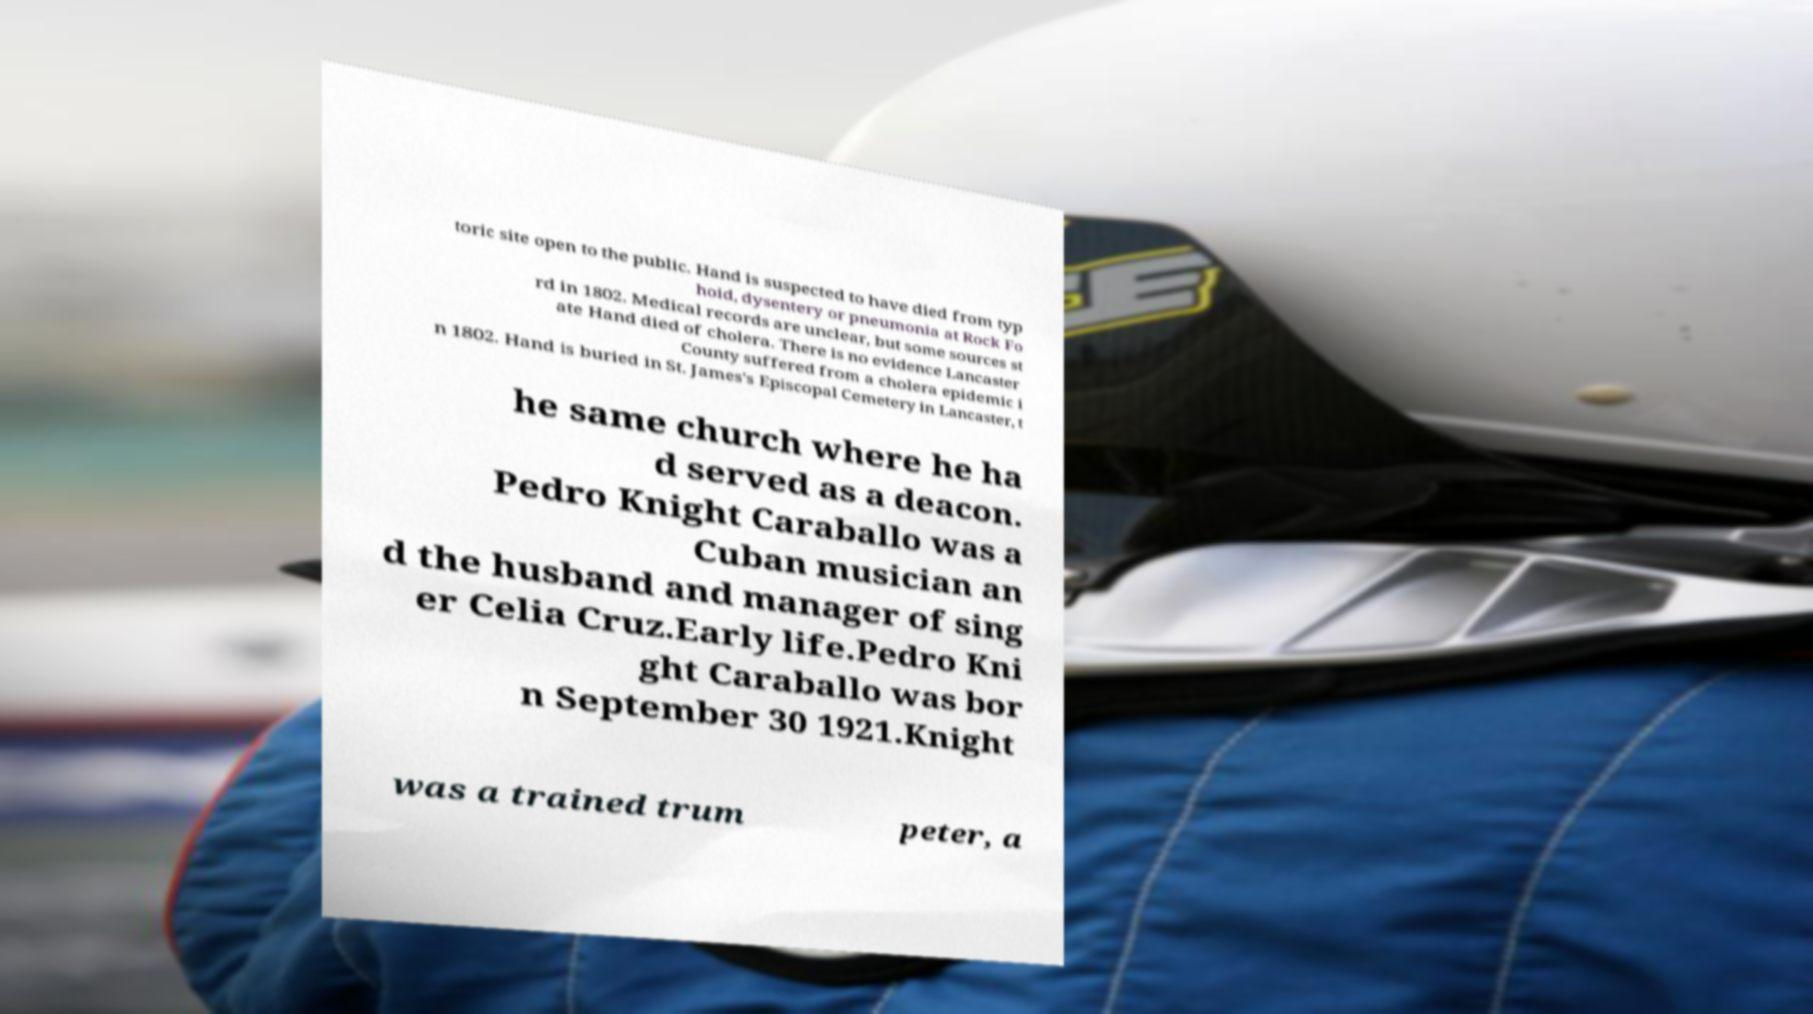Can you read and provide the text displayed in the image?This photo seems to have some interesting text. Can you extract and type it out for me? toric site open to the public. Hand is suspected to have died from typ hoid, dysentery or pneumonia at Rock Fo rd in 1802. Medical records are unclear, but some sources st ate Hand died of cholera. There is no evidence Lancaster County suffered from a cholera epidemic i n 1802. Hand is buried in St. James's Episcopal Cemetery in Lancaster, t he same church where he ha d served as a deacon. Pedro Knight Caraballo was a Cuban musician an d the husband and manager of sing er Celia Cruz.Early life.Pedro Kni ght Caraballo was bor n September 30 1921.Knight was a trained trum peter, a 